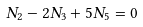<formula> <loc_0><loc_0><loc_500><loc_500>N _ { 2 } - 2 N _ { 3 } + 5 N _ { 5 } = 0</formula> 